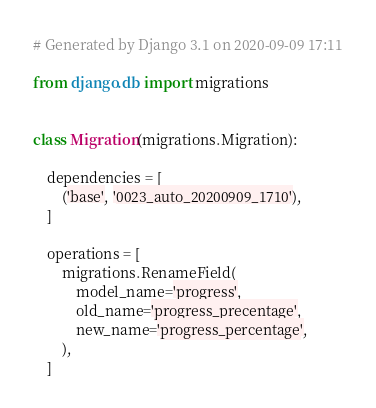<code> <loc_0><loc_0><loc_500><loc_500><_Python_># Generated by Django 3.1 on 2020-09-09 17:11

from django.db import migrations


class Migration(migrations.Migration):

    dependencies = [
        ('base', '0023_auto_20200909_1710'),
    ]

    operations = [
        migrations.RenameField(
            model_name='progress',
            old_name='progress_precentage',
            new_name='progress_percentage',
        ),
    ]
</code> 